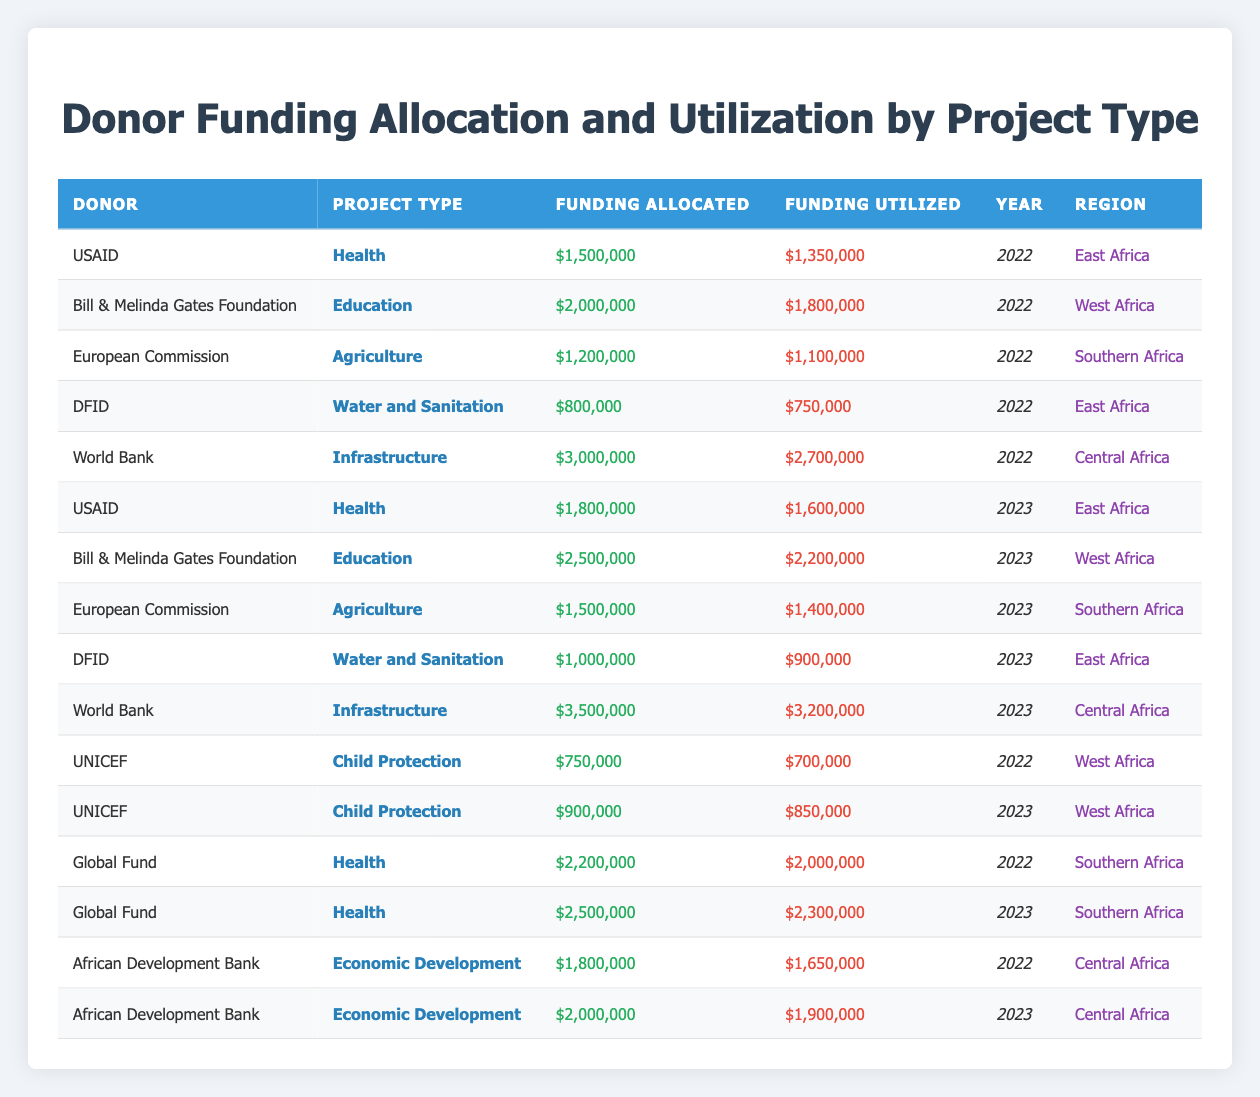What is the total funding allocated for Health projects by USAID in 2022 and 2023? Looking at rows for USAID under the project type "Health," the funding allocated in 2022 is $1,500,000 and in 2023 is $1,800,000. Summing these gives us a total of $1,500,000 + $1,800,000 = $3,300,000.
Answer: $3,300,000 Which donor had the highest funding utilization for Education projects in 2023? In 2023, the only donor funding Education projects is the Bill & Melinda Gates Foundation, with a funding utilization of $2,200,000. There are no other Education projects listed for that year.
Answer: Bill & Melinda Gates Foundation Did the funding allocated for Agriculture projects increase from 2022 to 2023? In 2022, the European Commission allocated $1,200,000 for Agriculture, and in 2023, they allocated $1,500,000. The difference is $1,500,000 - $1,200,000 = $300,000, indicating that the funding did increase.
Answer: Yes What is the funding utilization percentage for the World Bank's Infrastructure projects in 2023? The funding allocated by the World Bank for Infrastructure projects in 2023 is $3,500,000, and the funding utilized is $3,200,000. The utilization percentage is calculated as ($3,200,000 / $3,500,000) * 100, which equals approximately 91.43%.
Answer: 91.43% Is the funding utilized for the Child Protection project by UNICEF higher in 2023 than in 2022? In 2022, UNICEF utilized $700,000 for Child Protection, while in 2023, they utilized $850,000. Since $850,000 is greater than $700,000, the utilization is higher in 2023.
Answer: Yes What was the total funding allocated for all Economic Development projects over the years? The African Development Bank allocated $1,800,000 in 2022 and $2,000,000 in 2023, totaling $1,800,000 + $2,000,000 = $3,800,000 across both years for Economic Development projects.
Answer: $3,800,000 Which region received the most funding allocation in the year 2023? To find the region with the highest funding allocation in 2023, we check the funding allocated per region: East Africa received $1,800,000 (USAID Health) + $1,000,000 (DFID Water and Sanitation) = $2,800,000; West Africa received $2,500,000 (Bill & Melinda Gates Foundation Education); Southern Africa received $1,500,000 (European Commission Agriculture); and Central Africa received $3,500,000 (World Bank Infrastructure). The highest amount is in Central Africa with $3,500,000.
Answer: Central Africa What is the average funding utilized across all projects in 2022? First, we need to sum all the funding utilized in 2022: $1,350,000 (USAID Health) + $1,800,000 (Bill & Melinda Gates Foundation Education) + $1,100,000 (European Commission Agriculture) + $750,000 (DFID Water and Sanitation) + $2,700,000 (World Bank Infrastructure) + $700,000 (UNICEF Child Protection) + $2,000,000 (Global Fund Health) + $1,650,000 (African Development Bank Economic Development) = $12,150,000. There are 8 projects, so the average is $12,150,000 / 8 = $1,518,750.
Answer: $1,518,750 